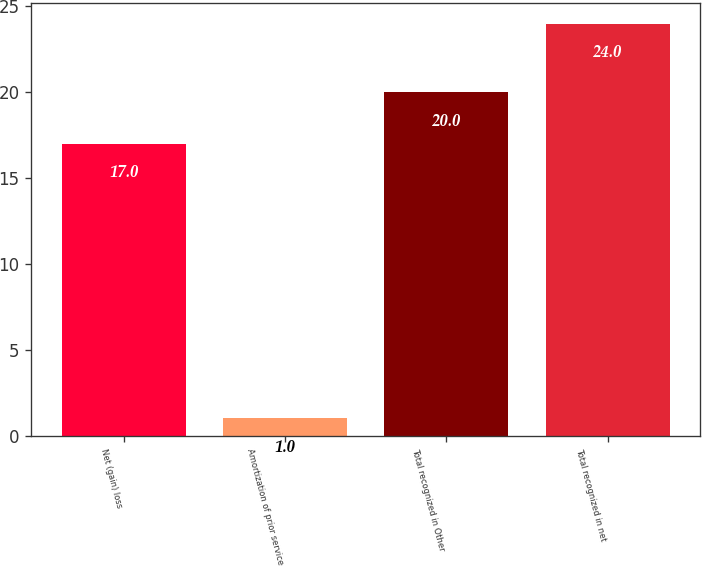Convert chart to OTSL. <chart><loc_0><loc_0><loc_500><loc_500><bar_chart><fcel>Net (gain) loss<fcel>Amortization of prior service<fcel>Total recognized in Other<fcel>Total recognized in net<nl><fcel>17<fcel>1<fcel>20<fcel>24<nl></chart> 